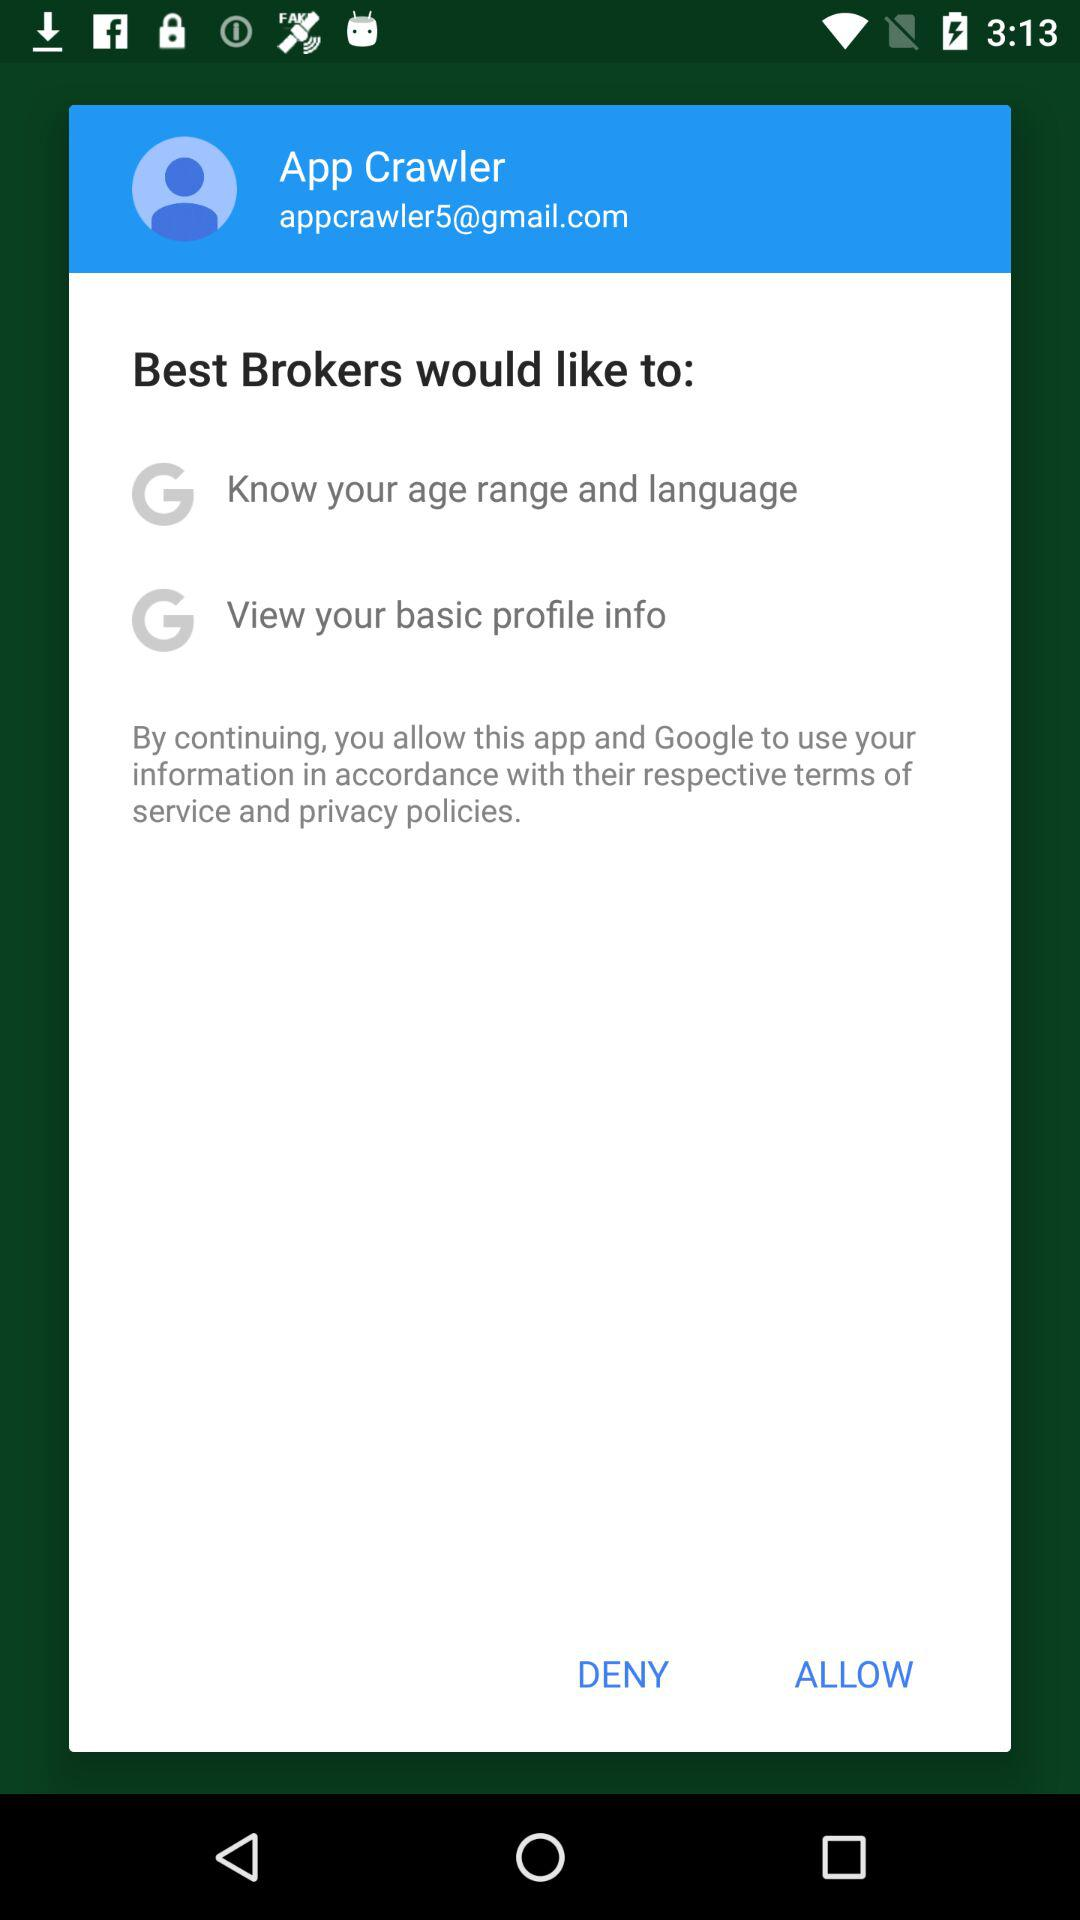What is the email address of App Crawler? The email address of App Crawler is appcrawler5@gmail.com. 